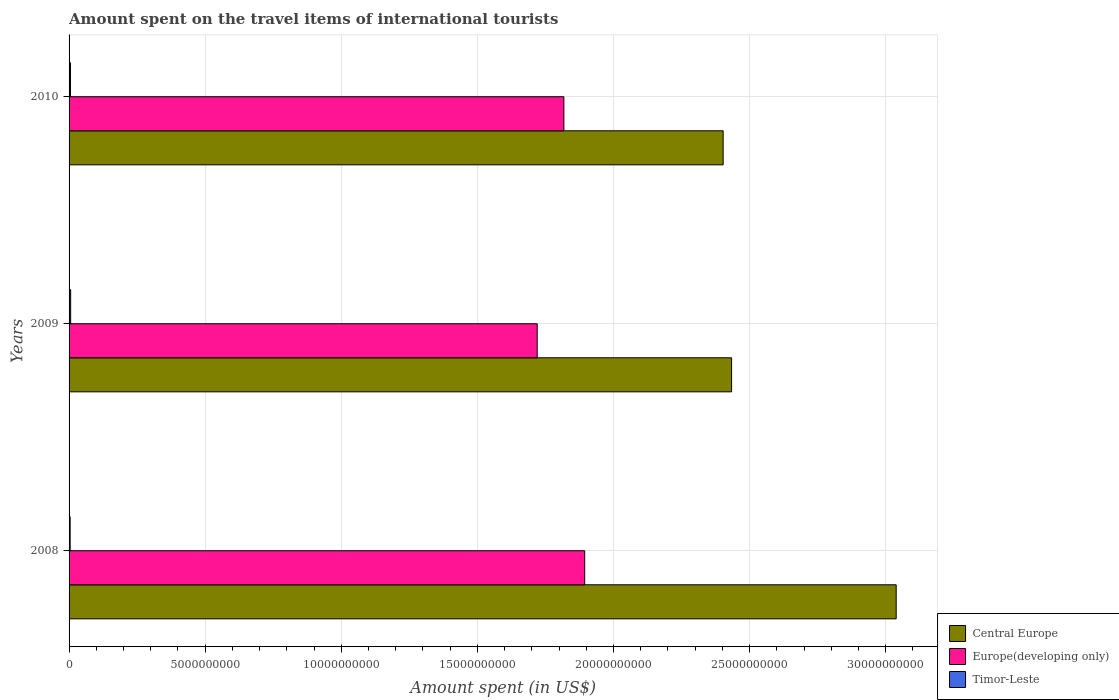How many different coloured bars are there?
Your answer should be compact. 3. How many bars are there on the 1st tick from the bottom?
Your answer should be compact. 3. What is the label of the 3rd group of bars from the top?
Keep it short and to the point. 2008. What is the amount spent on the travel items of international tourists in Europe(developing only) in 2009?
Offer a terse response. 1.72e+1. Across all years, what is the maximum amount spent on the travel items of international tourists in Central Europe?
Keep it short and to the point. 3.04e+1. Across all years, what is the minimum amount spent on the travel items of international tourists in Europe(developing only)?
Give a very brief answer. 1.72e+1. In which year was the amount spent on the travel items of international tourists in Europe(developing only) minimum?
Offer a terse response. 2009. What is the total amount spent on the travel items of international tourists in Timor-Leste in the graph?
Make the answer very short. 1.50e+08. What is the difference between the amount spent on the travel items of international tourists in Timor-Leste in 2008 and that in 2009?
Provide a succinct answer. -1.80e+07. What is the difference between the amount spent on the travel items of international tourists in Europe(developing only) in 2010 and the amount spent on the travel items of international tourists in Timor-Leste in 2009?
Make the answer very short. 1.81e+1. What is the average amount spent on the travel items of international tourists in Central Europe per year?
Your answer should be very brief. 2.62e+1. In the year 2008, what is the difference between the amount spent on the travel items of international tourists in Timor-Leste and amount spent on the travel items of international tourists in Europe(developing only)?
Your response must be concise. -1.89e+1. In how many years, is the amount spent on the travel items of international tourists in Central Europe greater than 9000000000 US$?
Provide a short and direct response. 3. What is the ratio of the amount spent on the travel items of international tourists in Europe(developing only) in 2008 to that in 2009?
Your response must be concise. 1.1. Is the difference between the amount spent on the travel items of international tourists in Timor-Leste in 2009 and 2010 greater than the difference between the amount spent on the travel items of international tourists in Europe(developing only) in 2009 and 2010?
Give a very brief answer. Yes. What is the difference between the highest and the second highest amount spent on the travel items of international tourists in Europe(developing only)?
Make the answer very short. 7.65e+08. What is the difference between the highest and the lowest amount spent on the travel items of international tourists in Europe(developing only)?
Your response must be concise. 1.74e+09. Is the sum of the amount spent on the travel items of international tourists in Central Europe in 2008 and 2010 greater than the maximum amount spent on the travel items of international tourists in Europe(developing only) across all years?
Offer a very short reply. Yes. What does the 1st bar from the top in 2008 represents?
Offer a very short reply. Timor-Leste. What does the 3rd bar from the bottom in 2009 represents?
Your response must be concise. Timor-Leste. How many bars are there?
Ensure brevity in your answer.  9. Are all the bars in the graph horizontal?
Provide a short and direct response. Yes. How many years are there in the graph?
Ensure brevity in your answer.  3. Are the values on the major ticks of X-axis written in scientific E-notation?
Offer a terse response. No. Does the graph contain any zero values?
Provide a succinct answer. No. Does the graph contain grids?
Provide a short and direct response. Yes. What is the title of the graph?
Your answer should be very brief. Amount spent on the travel items of international tourists. What is the label or title of the X-axis?
Provide a short and direct response. Amount spent (in US$). What is the Amount spent (in US$) in Central Europe in 2008?
Ensure brevity in your answer.  3.04e+1. What is the Amount spent (in US$) of Europe(developing only) in 2008?
Give a very brief answer. 1.89e+1. What is the Amount spent (in US$) of Timor-Leste in 2008?
Provide a succinct answer. 4.00e+07. What is the Amount spent (in US$) in Central Europe in 2009?
Give a very brief answer. 2.43e+1. What is the Amount spent (in US$) in Europe(developing only) in 2009?
Keep it short and to the point. 1.72e+1. What is the Amount spent (in US$) in Timor-Leste in 2009?
Make the answer very short. 5.80e+07. What is the Amount spent (in US$) of Central Europe in 2010?
Offer a very short reply. 2.40e+1. What is the Amount spent (in US$) of Europe(developing only) in 2010?
Give a very brief answer. 1.82e+1. What is the Amount spent (in US$) in Timor-Leste in 2010?
Offer a very short reply. 5.20e+07. Across all years, what is the maximum Amount spent (in US$) in Central Europe?
Your answer should be very brief. 3.04e+1. Across all years, what is the maximum Amount spent (in US$) of Europe(developing only)?
Provide a short and direct response. 1.89e+1. Across all years, what is the maximum Amount spent (in US$) of Timor-Leste?
Provide a short and direct response. 5.80e+07. Across all years, what is the minimum Amount spent (in US$) in Central Europe?
Your answer should be very brief. 2.40e+1. Across all years, what is the minimum Amount spent (in US$) in Europe(developing only)?
Make the answer very short. 1.72e+1. Across all years, what is the minimum Amount spent (in US$) of Timor-Leste?
Offer a terse response. 4.00e+07. What is the total Amount spent (in US$) in Central Europe in the graph?
Offer a terse response. 7.87e+1. What is the total Amount spent (in US$) of Europe(developing only) in the graph?
Make the answer very short. 5.43e+1. What is the total Amount spent (in US$) in Timor-Leste in the graph?
Your answer should be compact. 1.50e+08. What is the difference between the Amount spent (in US$) in Central Europe in 2008 and that in 2009?
Ensure brevity in your answer.  6.05e+09. What is the difference between the Amount spent (in US$) of Europe(developing only) in 2008 and that in 2009?
Your answer should be very brief. 1.74e+09. What is the difference between the Amount spent (in US$) of Timor-Leste in 2008 and that in 2009?
Make the answer very short. -1.80e+07. What is the difference between the Amount spent (in US$) of Central Europe in 2008 and that in 2010?
Offer a terse response. 6.36e+09. What is the difference between the Amount spent (in US$) of Europe(developing only) in 2008 and that in 2010?
Your response must be concise. 7.65e+08. What is the difference between the Amount spent (in US$) in Timor-Leste in 2008 and that in 2010?
Ensure brevity in your answer.  -1.20e+07. What is the difference between the Amount spent (in US$) in Central Europe in 2009 and that in 2010?
Offer a terse response. 3.11e+08. What is the difference between the Amount spent (in US$) in Europe(developing only) in 2009 and that in 2010?
Give a very brief answer. -9.80e+08. What is the difference between the Amount spent (in US$) of Timor-Leste in 2009 and that in 2010?
Keep it short and to the point. 6.00e+06. What is the difference between the Amount spent (in US$) in Central Europe in 2008 and the Amount spent (in US$) in Europe(developing only) in 2009?
Keep it short and to the point. 1.32e+1. What is the difference between the Amount spent (in US$) of Central Europe in 2008 and the Amount spent (in US$) of Timor-Leste in 2009?
Make the answer very short. 3.03e+1. What is the difference between the Amount spent (in US$) in Europe(developing only) in 2008 and the Amount spent (in US$) in Timor-Leste in 2009?
Offer a terse response. 1.89e+1. What is the difference between the Amount spent (in US$) of Central Europe in 2008 and the Amount spent (in US$) of Europe(developing only) in 2010?
Give a very brief answer. 1.22e+1. What is the difference between the Amount spent (in US$) of Central Europe in 2008 and the Amount spent (in US$) of Timor-Leste in 2010?
Your answer should be compact. 3.03e+1. What is the difference between the Amount spent (in US$) of Europe(developing only) in 2008 and the Amount spent (in US$) of Timor-Leste in 2010?
Offer a very short reply. 1.89e+1. What is the difference between the Amount spent (in US$) in Central Europe in 2009 and the Amount spent (in US$) in Europe(developing only) in 2010?
Keep it short and to the point. 6.16e+09. What is the difference between the Amount spent (in US$) in Central Europe in 2009 and the Amount spent (in US$) in Timor-Leste in 2010?
Offer a terse response. 2.43e+1. What is the difference between the Amount spent (in US$) of Europe(developing only) in 2009 and the Amount spent (in US$) of Timor-Leste in 2010?
Ensure brevity in your answer.  1.71e+1. What is the average Amount spent (in US$) in Central Europe per year?
Give a very brief answer. 2.62e+1. What is the average Amount spent (in US$) of Europe(developing only) per year?
Your answer should be very brief. 1.81e+1. What is the average Amount spent (in US$) in Timor-Leste per year?
Make the answer very short. 5.00e+07. In the year 2008, what is the difference between the Amount spent (in US$) in Central Europe and Amount spent (in US$) in Europe(developing only)?
Provide a succinct answer. 1.14e+1. In the year 2008, what is the difference between the Amount spent (in US$) of Central Europe and Amount spent (in US$) of Timor-Leste?
Give a very brief answer. 3.03e+1. In the year 2008, what is the difference between the Amount spent (in US$) in Europe(developing only) and Amount spent (in US$) in Timor-Leste?
Offer a terse response. 1.89e+1. In the year 2009, what is the difference between the Amount spent (in US$) in Central Europe and Amount spent (in US$) in Europe(developing only)?
Make the answer very short. 7.14e+09. In the year 2009, what is the difference between the Amount spent (in US$) of Central Europe and Amount spent (in US$) of Timor-Leste?
Your response must be concise. 2.43e+1. In the year 2009, what is the difference between the Amount spent (in US$) in Europe(developing only) and Amount spent (in US$) in Timor-Leste?
Make the answer very short. 1.71e+1. In the year 2010, what is the difference between the Amount spent (in US$) of Central Europe and Amount spent (in US$) of Europe(developing only)?
Your answer should be very brief. 5.85e+09. In the year 2010, what is the difference between the Amount spent (in US$) in Central Europe and Amount spent (in US$) in Timor-Leste?
Your response must be concise. 2.40e+1. In the year 2010, what is the difference between the Amount spent (in US$) in Europe(developing only) and Amount spent (in US$) in Timor-Leste?
Give a very brief answer. 1.81e+1. What is the ratio of the Amount spent (in US$) in Central Europe in 2008 to that in 2009?
Provide a succinct answer. 1.25. What is the ratio of the Amount spent (in US$) in Europe(developing only) in 2008 to that in 2009?
Give a very brief answer. 1.1. What is the ratio of the Amount spent (in US$) in Timor-Leste in 2008 to that in 2009?
Your answer should be very brief. 0.69. What is the ratio of the Amount spent (in US$) in Central Europe in 2008 to that in 2010?
Offer a terse response. 1.26. What is the ratio of the Amount spent (in US$) in Europe(developing only) in 2008 to that in 2010?
Provide a short and direct response. 1.04. What is the ratio of the Amount spent (in US$) in Timor-Leste in 2008 to that in 2010?
Make the answer very short. 0.77. What is the ratio of the Amount spent (in US$) of Central Europe in 2009 to that in 2010?
Ensure brevity in your answer.  1.01. What is the ratio of the Amount spent (in US$) in Europe(developing only) in 2009 to that in 2010?
Offer a terse response. 0.95. What is the ratio of the Amount spent (in US$) of Timor-Leste in 2009 to that in 2010?
Ensure brevity in your answer.  1.12. What is the difference between the highest and the second highest Amount spent (in US$) of Central Europe?
Your response must be concise. 6.05e+09. What is the difference between the highest and the second highest Amount spent (in US$) of Europe(developing only)?
Give a very brief answer. 7.65e+08. What is the difference between the highest and the lowest Amount spent (in US$) of Central Europe?
Your answer should be very brief. 6.36e+09. What is the difference between the highest and the lowest Amount spent (in US$) of Europe(developing only)?
Your answer should be compact. 1.74e+09. What is the difference between the highest and the lowest Amount spent (in US$) of Timor-Leste?
Give a very brief answer. 1.80e+07. 